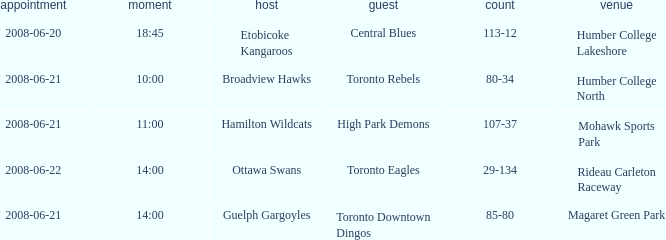What is the Time with a Ground that is humber college north? 10:00. 